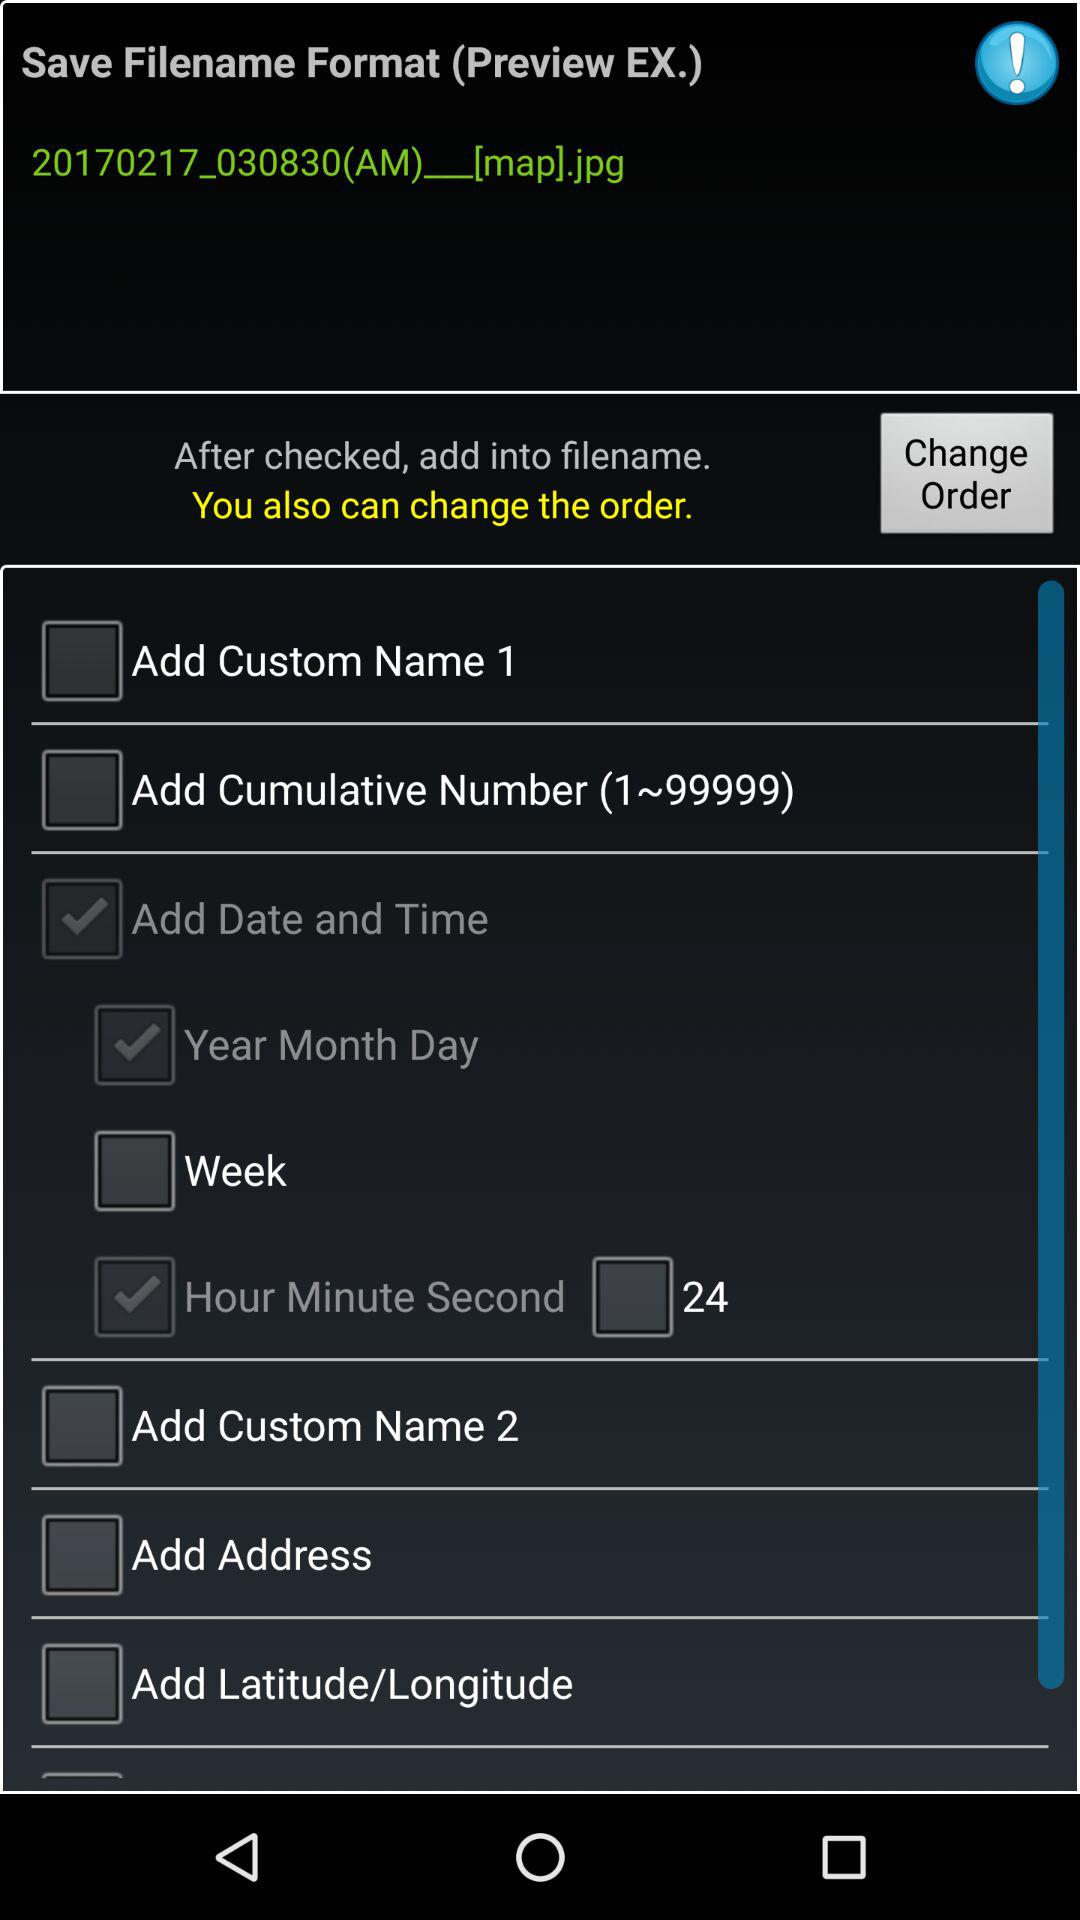Which options are selected? The selected options are "Add Date and Time", "Year Month Day" and "Hour Minute Second". 